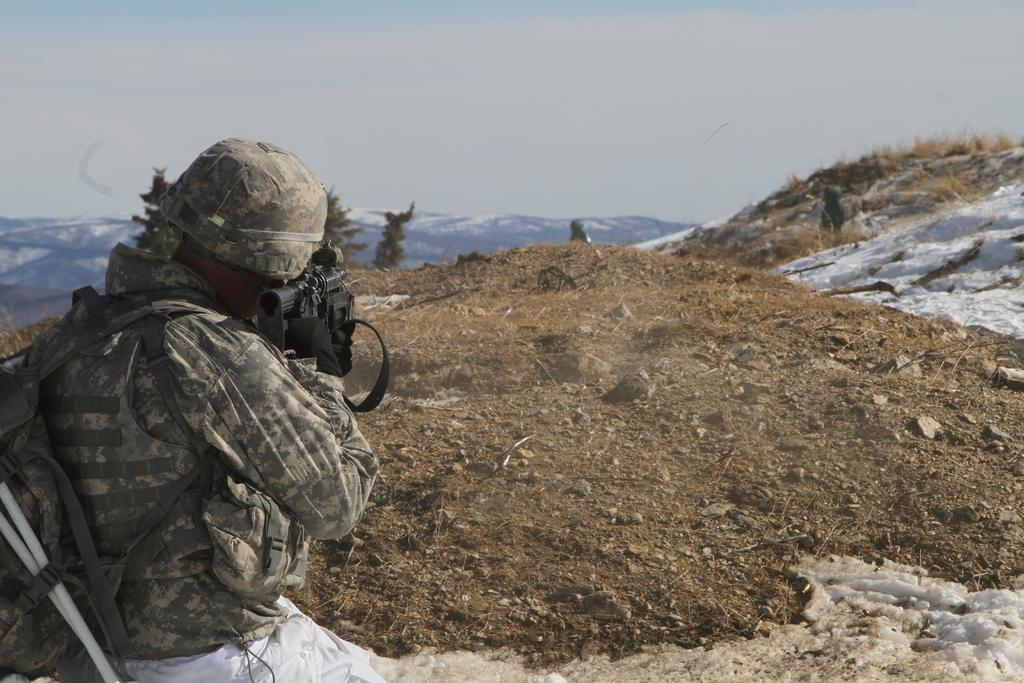What is the main subject of the image? There is a soldier in the image. What is the soldier carrying? The soldier is carrying a gun and a bag. What can be seen on the ground in the image? There are stones and a rock on the ground. What is visible in the background of the image? There are mountains and trees in the background. What part of the natural environment is visible in the image? The sky is visible in the image. What page of the book is the soldier reading in the image? There is no book present in the image, so it is not possible to determine which page the soldier might be reading. 